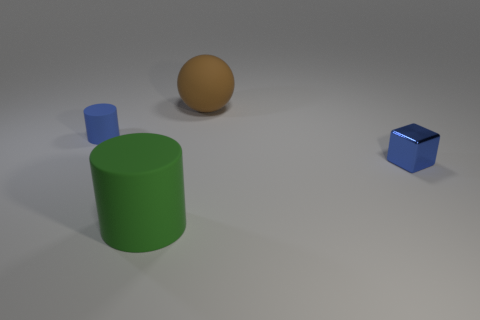What color is the matte cylinder that is left of the large green thing?
Ensure brevity in your answer.  Blue. There is a tiny block that is the same color as the small rubber cylinder; what is its material?
Ensure brevity in your answer.  Metal. What number of matte spheres have the same color as the tiny rubber thing?
Provide a short and direct response. 0. There is a ball; does it have the same size as the rubber cylinder in front of the block?
Make the answer very short. Yes. What is the size of the matte cylinder that is in front of the rubber cylinder that is behind the large object that is in front of the brown sphere?
Your response must be concise. Large. There is a brown sphere; what number of rubber spheres are to the right of it?
Give a very brief answer. 0. What is the material of the cylinder behind the small blue thing to the right of the large brown thing?
Make the answer very short. Rubber. Is there anything else that has the same size as the green matte cylinder?
Provide a short and direct response. Yes. Do the blue block and the green object have the same size?
Make the answer very short. No. What number of objects are either objects to the left of the brown sphere or tiny blue objects that are behind the tiny blue metal thing?
Make the answer very short. 2. 